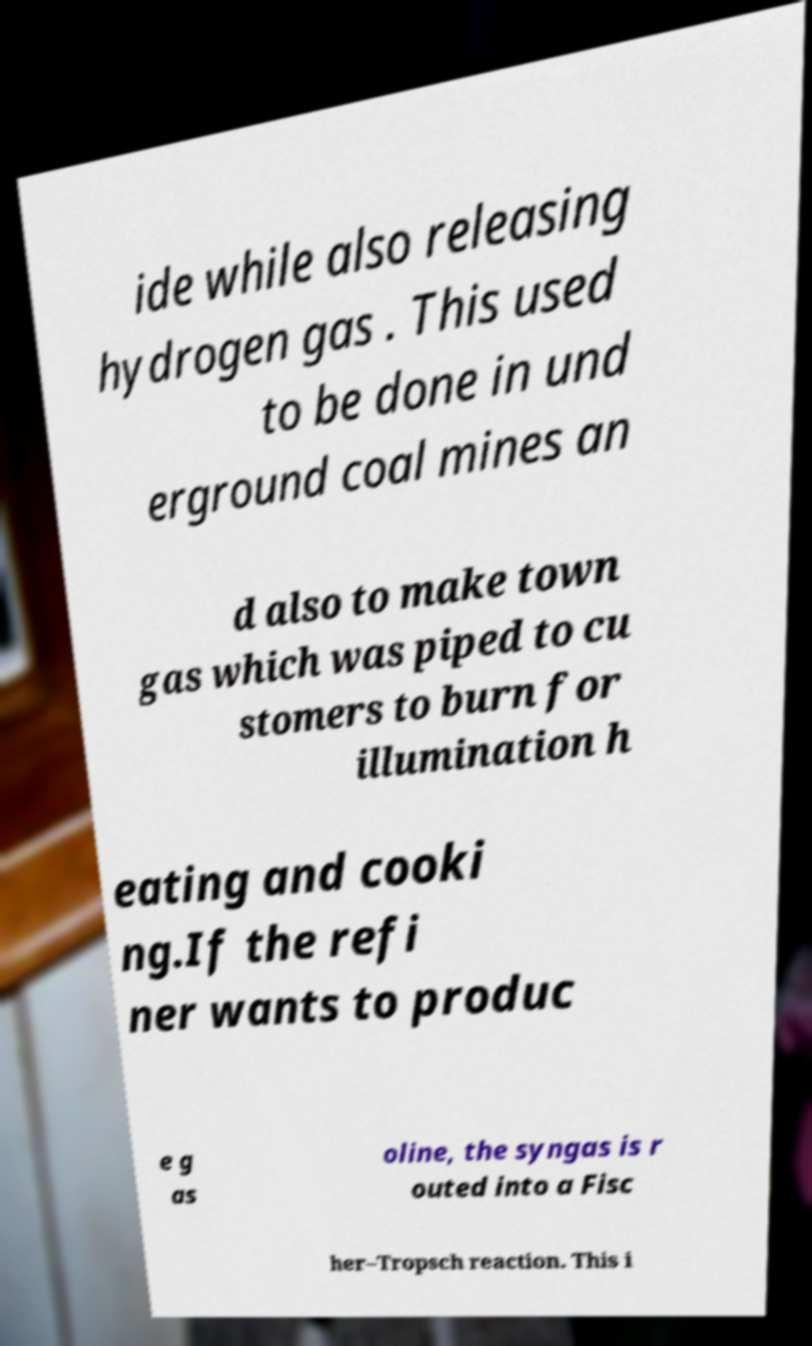Can you read and provide the text displayed in the image?This photo seems to have some interesting text. Can you extract and type it out for me? ide while also releasing hydrogen gas . This used to be done in und erground coal mines an d also to make town gas which was piped to cu stomers to burn for illumination h eating and cooki ng.If the refi ner wants to produc e g as oline, the syngas is r outed into a Fisc her–Tropsch reaction. This i 